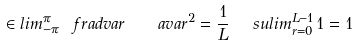Convert formula to latex. <formula><loc_0><loc_0><loc_500><loc_500>\in l i m ^ { \pi } _ { - \pi } \, \ f r a d v a r \quad a v a r ^ { 2 } = \frac { 1 } { L } \ \ s u l i m ^ { L - 1 } _ { r = 0 } \, 1 = 1</formula> 